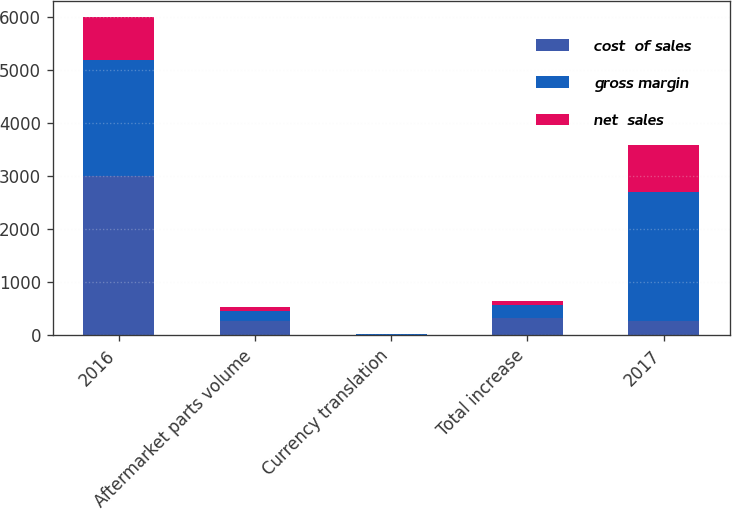Convert chart. <chart><loc_0><loc_0><loc_500><loc_500><stacked_bar_chart><ecel><fcel>2016<fcel>Aftermarket parts volume<fcel>Currency translation<fcel>Total increase<fcel>2017<nl><fcel>cost  of sales<fcel>3005.7<fcel>270<fcel>5.4<fcel>321.3<fcel>259.7<nl><fcel>gross margin<fcel>2196.4<fcel>183.6<fcel>10.3<fcel>249.4<fcel>2445.8<nl><fcel>net  sales<fcel>809.3<fcel>86.4<fcel>4.9<fcel>71.9<fcel>881.2<nl></chart> 